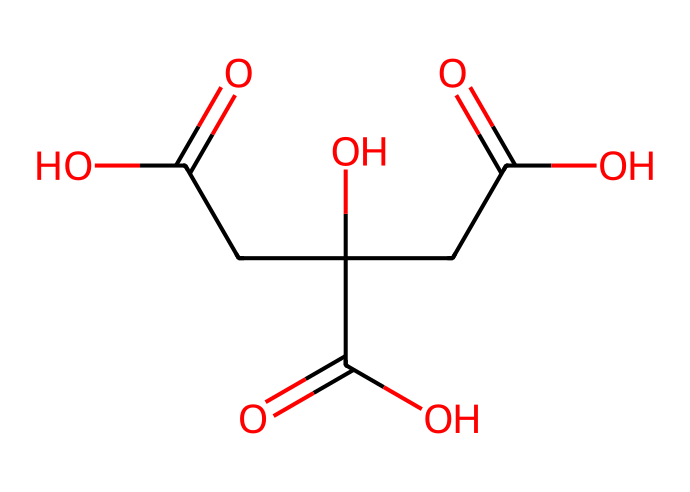What is the name of this chemical? The chemical represented by the provided SMILES is citric acid. This can be identified by the specific arrangement of carboxylic acid functional groups, indicated by the presence of C(=O)O groups and the overall structure common to citric acid.
Answer: citric acid How many carbon atoms are in citric acid? By analyzing the SMILES, there are a total of six carbon atoms (C). The structure includes a linear and branched arrangement where each carbon is accounted for in the chemical formula.
Answer: six How many hydroxyl groups does citric acid contain? The structure shows the presence of three hydroxyl (-OH) groups. This can be confirmed by counting the -OH groups attached to the carbon skeleton within the SMILES.
Answer: three What type of functional groups are present in citric acid? The chemical features multiple carboxylic acid functional groups, as indicated by the -COOH groups in the structure. These functional groups characterize citric acid and its acid behavior.
Answer: carboxylic acid What is the molecular weight of citric acid? The molecular weight can be calculated based on the number of each type of atom present in citric acid: C6 (6 carbons), H8 (8 hydrogens), and O7 (7 oxygens), resulting in a molecular weight of approximately 192 grams per mole.
Answer: 192 How does the structure of citric acid influence its role as a solvent? The presence of hydroxyl and carboxylic acid groups enhances the polarity of citric acid, making it effective in dissolving ionic and polar substances. This interaction is crucial for its application in household cleaners.
Answer: enhances polarity 